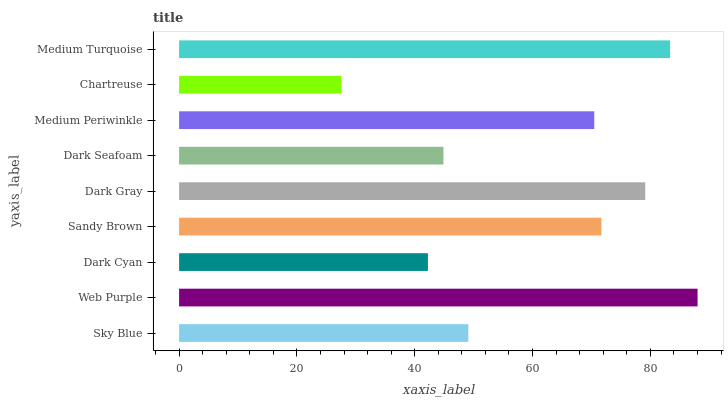Is Chartreuse the minimum?
Answer yes or no. Yes. Is Web Purple the maximum?
Answer yes or no. Yes. Is Dark Cyan the minimum?
Answer yes or no. No. Is Dark Cyan the maximum?
Answer yes or no. No. Is Web Purple greater than Dark Cyan?
Answer yes or no. Yes. Is Dark Cyan less than Web Purple?
Answer yes or no. Yes. Is Dark Cyan greater than Web Purple?
Answer yes or no. No. Is Web Purple less than Dark Cyan?
Answer yes or no. No. Is Medium Periwinkle the high median?
Answer yes or no. Yes. Is Medium Periwinkle the low median?
Answer yes or no. Yes. Is Sky Blue the high median?
Answer yes or no. No. Is Dark Seafoam the low median?
Answer yes or no. No. 